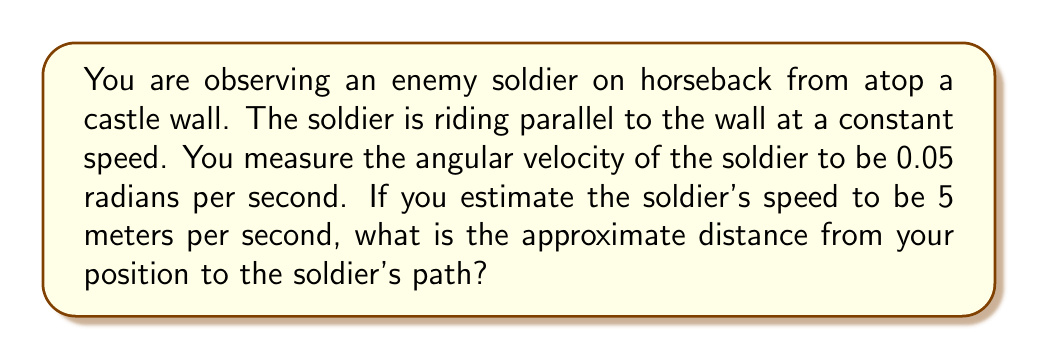Provide a solution to this math problem. To solve this problem, we'll use the relationship between angular velocity, linear velocity, and radius (distance).

1) Let's define our variables:
   $\omega$ = angular velocity = 0.05 rad/s
   $v$ = linear velocity = 5 m/s
   $r$ = radius (distance to the path)

2) The relationship between these variables is:
   $v = r\omega$

3) Rearranging this equation to solve for $r$:
   $r = \frac{v}{\omega}$

4) Now we can substitute our known values:
   $r = \frac{5 \text{ m/s}}{0.05 \text{ rad/s}}$

5) Simplifying:
   $r = 100 \text{ m}$

Therefore, the distance from your position to the soldier's path is approximately 100 meters.

[asy]
import geometry;

size(200);

pair A = (0,0);
pair B = (4,0);
pair C = (4,3);

draw(A--B--C--A);
draw((-1,0)--(5,0), arrow=Arrow(TeXHead));
label("Soldier's path", (2,-0.5));
label("Wall", (4,1.5), E);
label("You", (0,0), W);
label("100 m", (2,1.5), N);

dot("Soldier", B, S);
dot("You", A, W);
[/asy]
Answer: The approximate distance from your position to the soldier's path is 100 meters. 